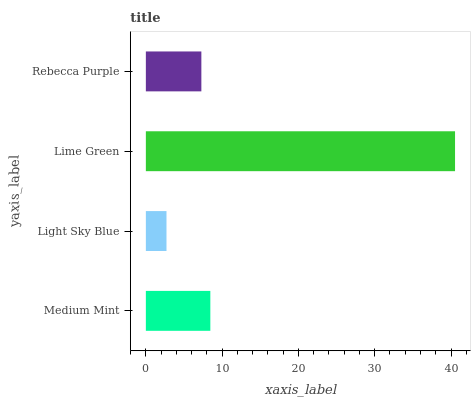Is Light Sky Blue the minimum?
Answer yes or no. Yes. Is Lime Green the maximum?
Answer yes or no. Yes. Is Lime Green the minimum?
Answer yes or no. No. Is Light Sky Blue the maximum?
Answer yes or no. No. Is Lime Green greater than Light Sky Blue?
Answer yes or no. Yes. Is Light Sky Blue less than Lime Green?
Answer yes or no. Yes. Is Light Sky Blue greater than Lime Green?
Answer yes or no. No. Is Lime Green less than Light Sky Blue?
Answer yes or no. No. Is Medium Mint the high median?
Answer yes or no. Yes. Is Rebecca Purple the low median?
Answer yes or no. Yes. Is Lime Green the high median?
Answer yes or no. No. Is Medium Mint the low median?
Answer yes or no. No. 